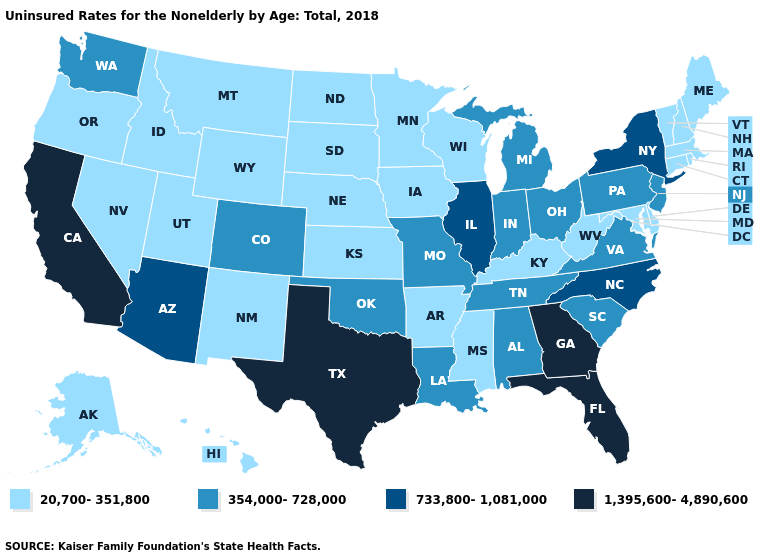Does the map have missing data?
Write a very short answer. No. What is the highest value in the MidWest ?
Write a very short answer. 733,800-1,081,000. Does Florida have the highest value in the USA?
Quick response, please. Yes. What is the value of Iowa?
Short answer required. 20,700-351,800. Which states have the lowest value in the Northeast?
Write a very short answer. Connecticut, Maine, Massachusetts, New Hampshire, Rhode Island, Vermont. What is the highest value in the MidWest ?
Write a very short answer. 733,800-1,081,000. What is the value of New Hampshire?
Short answer required. 20,700-351,800. What is the value of Minnesota?
Write a very short answer. 20,700-351,800. What is the value of Alabama?
Keep it brief. 354,000-728,000. Which states have the lowest value in the USA?
Quick response, please. Alaska, Arkansas, Connecticut, Delaware, Hawaii, Idaho, Iowa, Kansas, Kentucky, Maine, Maryland, Massachusetts, Minnesota, Mississippi, Montana, Nebraska, Nevada, New Hampshire, New Mexico, North Dakota, Oregon, Rhode Island, South Dakota, Utah, Vermont, West Virginia, Wisconsin, Wyoming. What is the highest value in the Northeast ?
Short answer required. 733,800-1,081,000. Name the states that have a value in the range 733,800-1,081,000?
Be succinct. Arizona, Illinois, New York, North Carolina. What is the lowest value in the South?
Give a very brief answer. 20,700-351,800. Name the states that have a value in the range 733,800-1,081,000?
Concise answer only. Arizona, Illinois, New York, North Carolina. What is the value of Louisiana?
Write a very short answer. 354,000-728,000. 